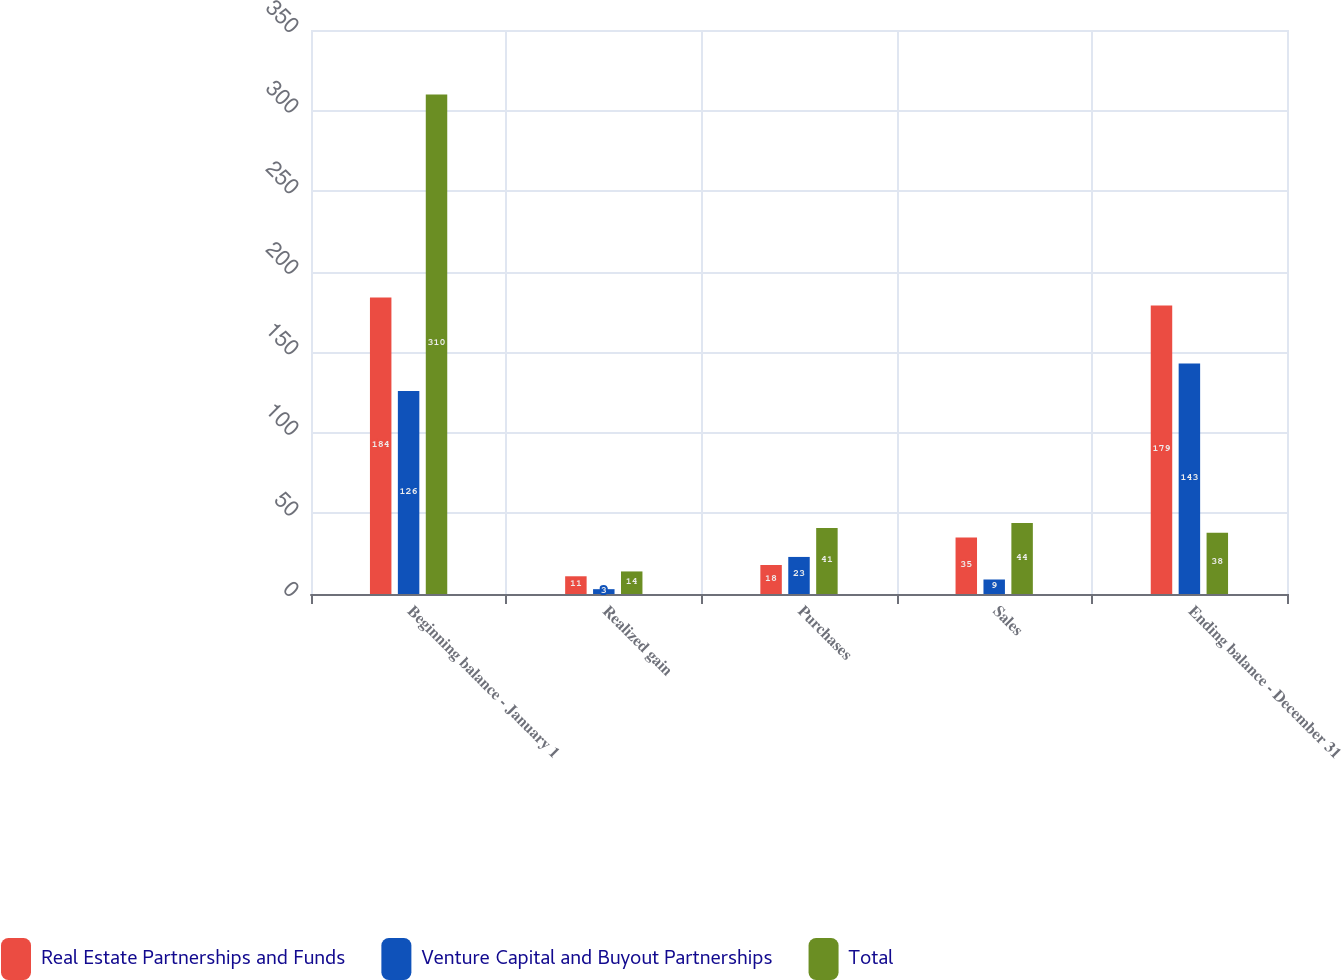Convert chart. <chart><loc_0><loc_0><loc_500><loc_500><stacked_bar_chart><ecel><fcel>Beginning balance - January 1<fcel>Realized gain<fcel>Purchases<fcel>Sales<fcel>Ending balance - December 31<nl><fcel>Real Estate Partnerships and Funds<fcel>184<fcel>11<fcel>18<fcel>35<fcel>179<nl><fcel>Venture Capital and Buyout Partnerships<fcel>126<fcel>3<fcel>23<fcel>9<fcel>143<nl><fcel>Total<fcel>310<fcel>14<fcel>41<fcel>44<fcel>38<nl></chart> 